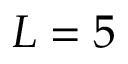<formula> <loc_0><loc_0><loc_500><loc_500>L = 5</formula> 